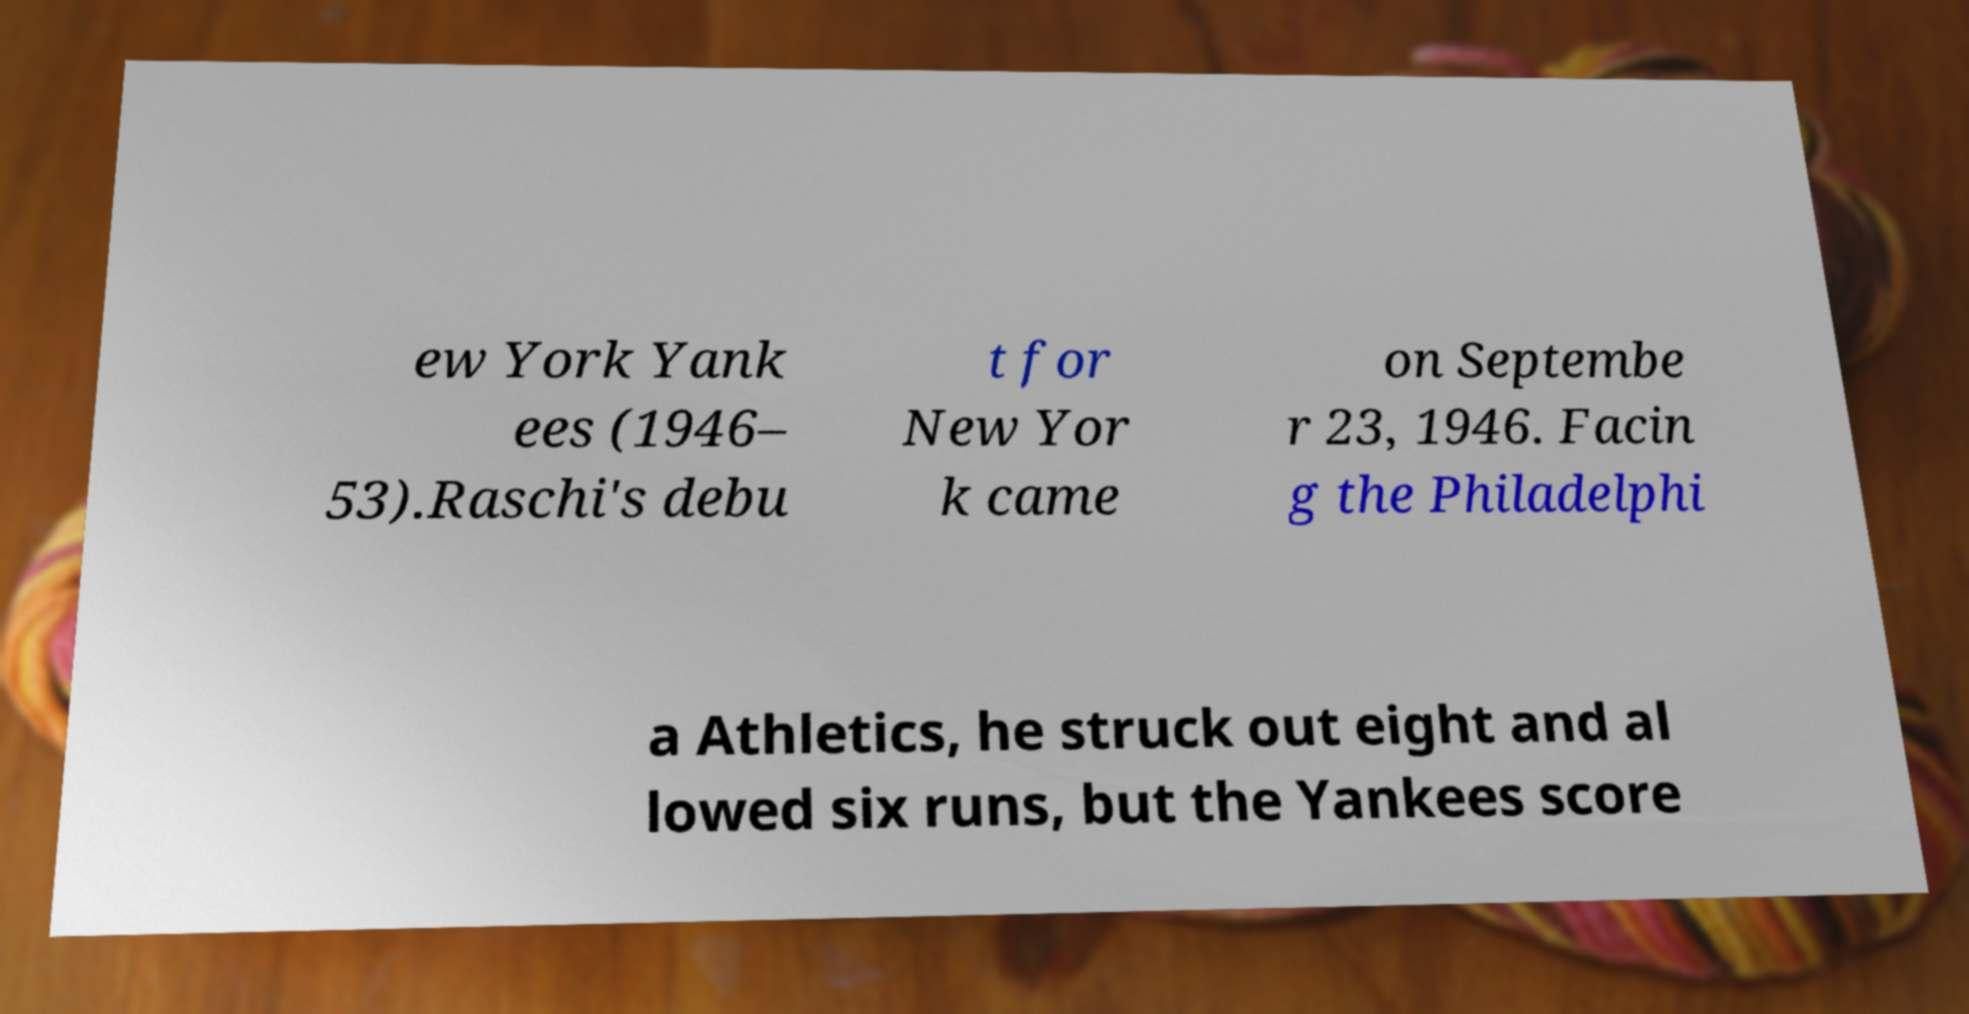Can you accurately transcribe the text from the provided image for me? ew York Yank ees (1946– 53).Raschi's debu t for New Yor k came on Septembe r 23, 1946. Facin g the Philadelphi a Athletics, he struck out eight and al lowed six runs, but the Yankees score 